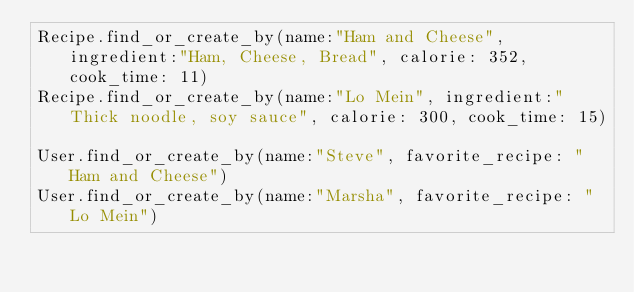Convert code to text. <code><loc_0><loc_0><loc_500><loc_500><_Ruby_>Recipe.find_or_create_by(name:"Ham and Cheese", ingredient:"Ham, Cheese, Bread", calorie: 352, cook_time: 11)
Recipe.find_or_create_by(name:"Lo Mein", ingredient:"Thick noodle, soy sauce", calorie: 300, cook_time: 15)

User.find_or_create_by(name:"Steve", favorite_recipe: "Ham and Cheese")
User.find_or_create_by(name:"Marsha", favorite_recipe: "Lo Mein")

</code> 